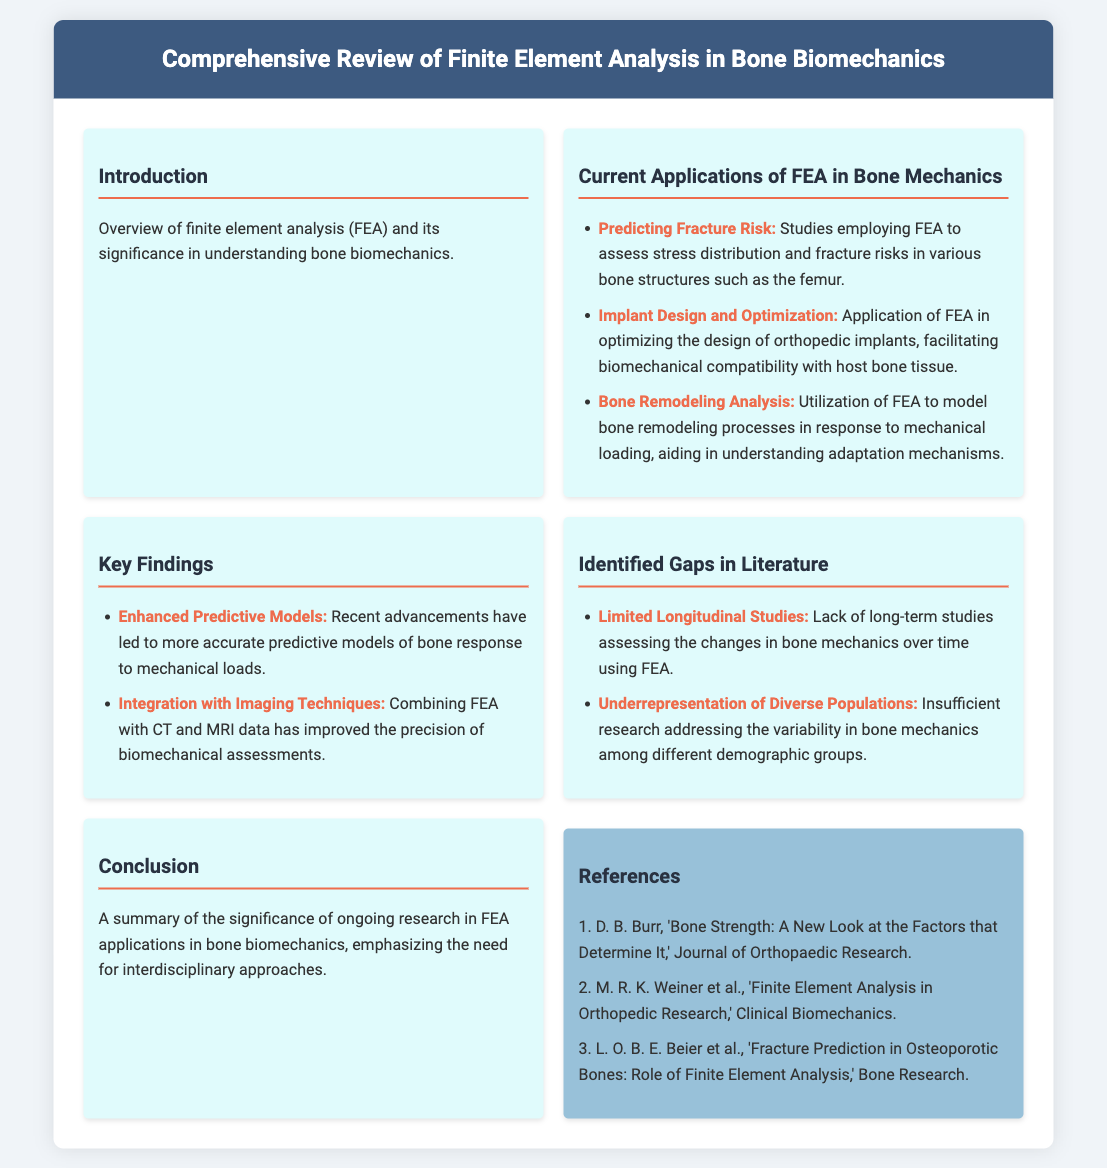what is the title of the document? The title is stated in the header section of the document.
Answer: Comprehensive Review of Finite Element Analysis in Bone Biomechanics what is one application of FEA mentioned in the document? The document lists various applications in the section dedicated to current applications of FEA.
Answer: Predicting Fracture Risk what does FEA stand for? The document provides the full form of FEA in the introduction section.
Answer: Finite Element Analysis what is a key finding related to predictive models? The key findings section highlights advancements in predictive models.
Answer: Enhanced Predictive Models what gap in literature is identified regarding study duration? The identified gaps section mentions limitations on study duration.
Answer: Limited Longitudinal Studies how many references are listed in the document? The number of references is indicated in the references section at the bottom of the document.
Answer: 3 what imaging techniques are integrated with FEA? The key findings section mentions imaging techniques that enhance biomechanical assessments.
Answer: CT and MRI what is one focus of the conclusion? The conclusion summarizes the importance of ongoing research in specific areas.
Answer: Interdisciplinary approaches 